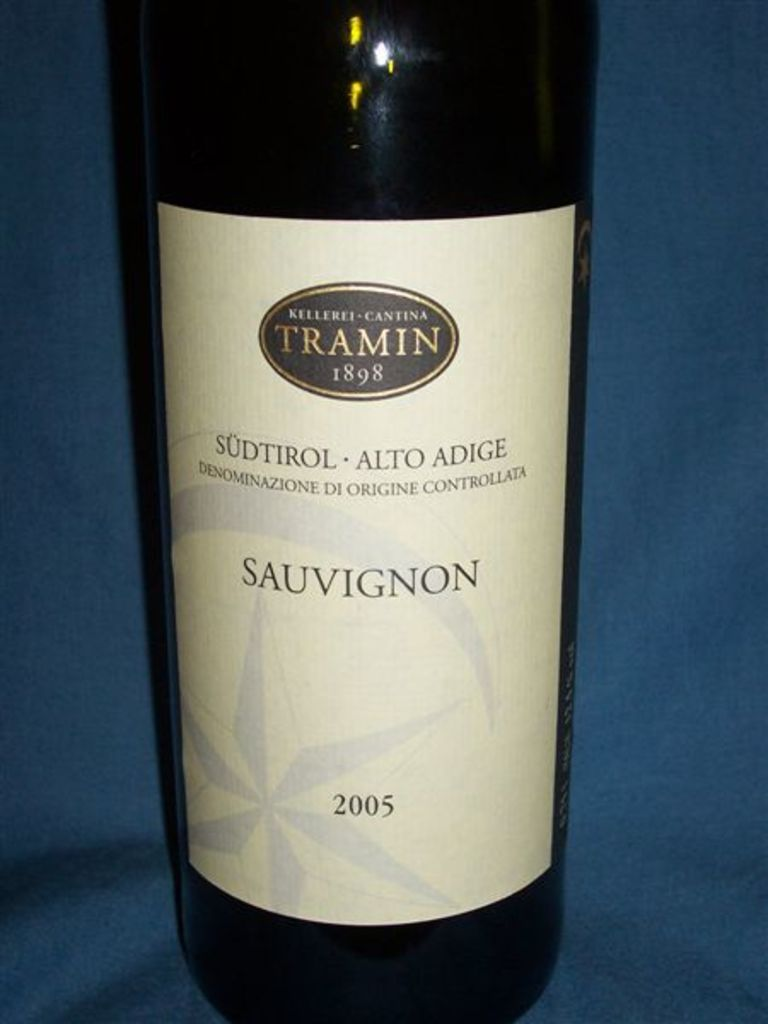What might the 2005 vintage suggest about this Sauvignon? The 2005 vintage was generally excellent in many parts of Italy, including Südtirol, known for balanced weather conditions that led to optimal ripening of grapes. Wines from this year, such as the Sauvignon shown, are often characterized by their maturity and robust flavors. You can expect a well-rounded wine with developed aromas and a complex palate that reflects the aging potential of well-made Sauvignons from this region. It's likely to offer a harmonious blend of fruit and mineral notes, possibly with hints of aged characteristics like a touch of nuttiness or earthy undertones. 